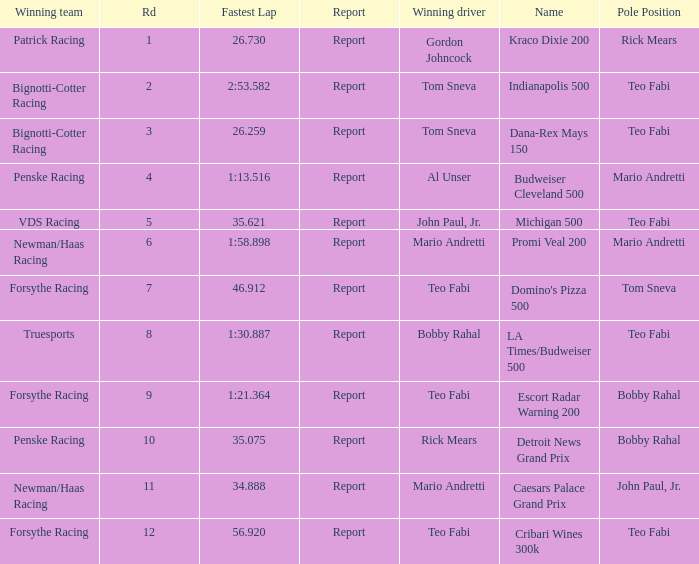Which Rd took place at the Indianapolis 500? 2.0. 